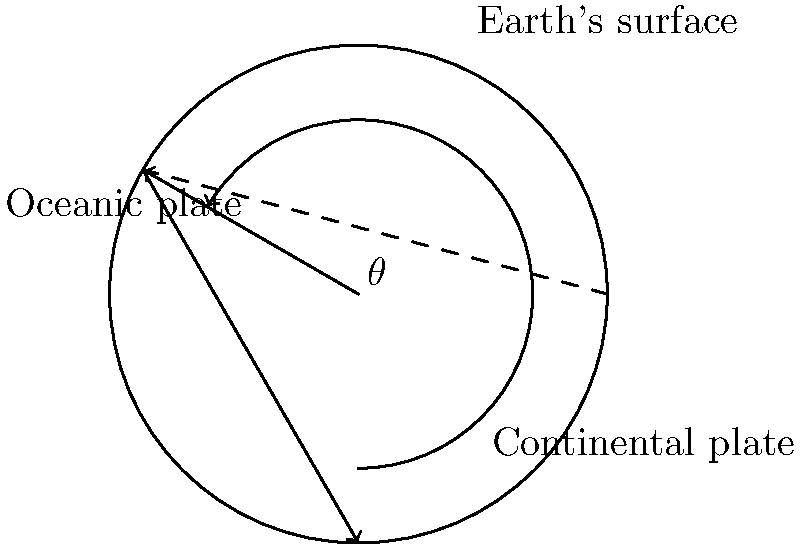In the cross-sectional diagram of the Earth's crust shown above, an oceanic plate is subducting beneath a continental plate. The angle of subduction ($\theta$) is crucial for understanding the environmental impacts of this tectonic activity. If the depth of the subduction zone is 200 km and the horizontal distance from the trench to the point where the oceanic plate reaches this depth is 346 km, what is the angle of subduction ($\theta$) to the nearest degree? To solve this problem, we can use trigonometry. The scenario describes a right-angled triangle where:

1) The opposite side is the depth of the subduction zone: 200 km
2) The adjacent side is the horizontal distance: 346 km
3) The angle we're looking for is $\theta$

We can use the tangent function to find this angle:

$$\tan(\theta) = \frac{\text{opposite}}{\text{adjacent}} = \frac{200}{346}$$

To find $\theta$, we need to use the inverse tangent (arctangent) function:

$$\theta = \arctan(\frac{200}{346})$$

Using a calculator or computer:

$$\theta \approx 30.0384 \text{ degrees}$$

Rounding to the nearest degree:

$$\theta \approx 30 \text{ degrees}$$

This angle of subduction has significant environmental implications. Steeper angles (closer to 90°) generally result in more violent volcanic eruptions and earthquakes, while shallower angles (closer to 0°) tend to create longer volcanic arcs and more gradual mountain building.
Answer: 30° 